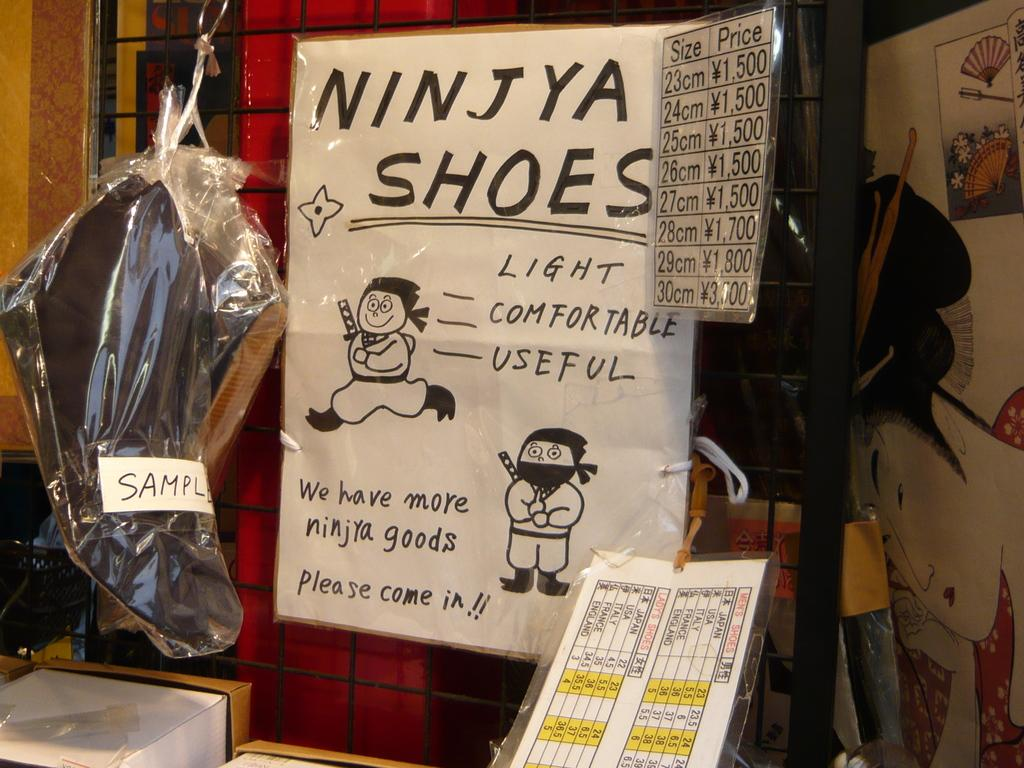<image>
Present a compact description of the photo's key features. White sign that shows a ninja and says "We have more ninja goods". 